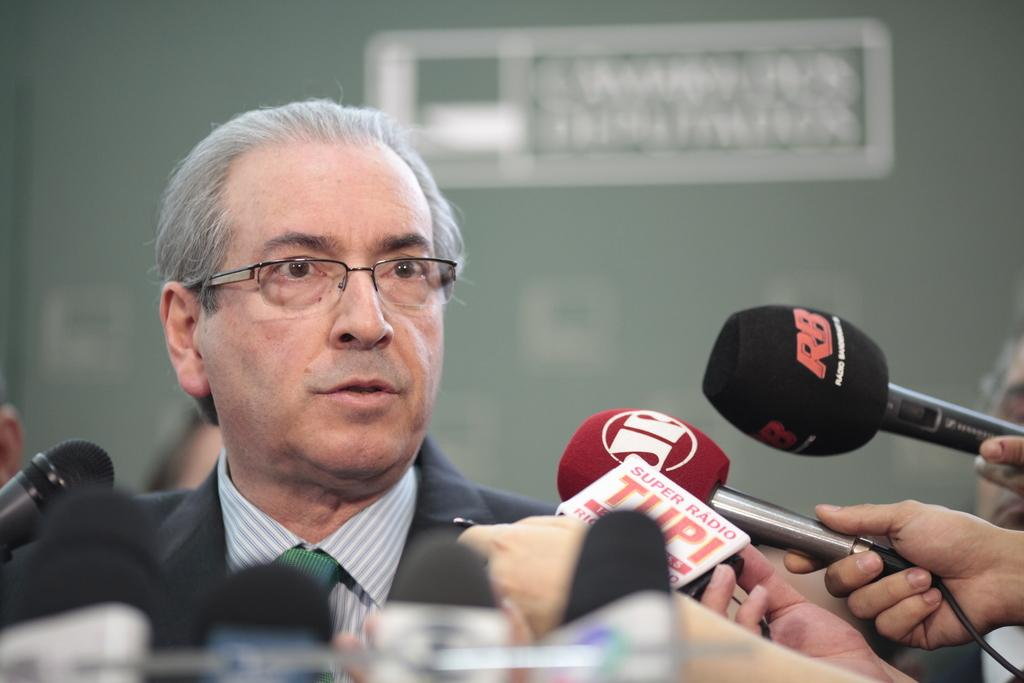Who is the main subject in the picture? The main subject in the picture is an old man. What is the old man wearing? The old man is wearing a black coat and specs. What is the old man doing in the picture? The old man is talking with media. How many microphones are in front of the old man? There are many microphones in front of the old man. What color is the wall behind the old man? The wall behind the old man is grey. Can you hear the alarm going off in the image? There is no alarm present in the image, so it cannot be heard. What type of field is visible in the image? There is no field visible in the image; it features an old man talking with media in front of a grey wall. 